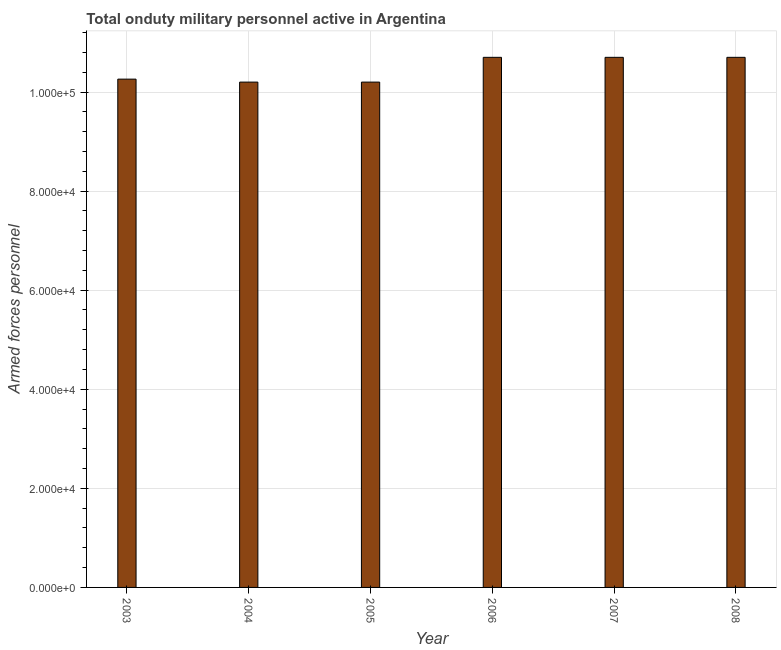Does the graph contain any zero values?
Give a very brief answer. No. Does the graph contain grids?
Offer a very short reply. Yes. What is the title of the graph?
Provide a succinct answer. Total onduty military personnel active in Argentina. What is the label or title of the Y-axis?
Your response must be concise. Armed forces personnel. What is the number of armed forces personnel in 2007?
Provide a short and direct response. 1.07e+05. Across all years, what is the maximum number of armed forces personnel?
Ensure brevity in your answer.  1.07e+05. Across all years, what is the minimum number of armed forces personnel?
Provide a short and direct response. 1.02e+05. What is the sum of the number of armed forces personnel?
Ensure brevity in your answer.  6.28e+05. What is the average number of armed forces personnel per year?
Your answer should be very brief. 1.05e+05. What is the median number of armed forces personnel?
Your answer should be very brief. 1.05e+05. What is the ratio of the number of armed forces personnel in 2007 to that in 2008?
Provide a succinct answer. 1. Is the number of armed forces personnel in 2003 less than that in 2005?
Your answer should be compact. No. Is the difference between the number of armed forces personnel in 2004 and 2006 greater than the difference between any two years?
Make the answer very short. Yes. In how many years, is the number of armed forces personnel greater than the average number of armed forces personnel taken over all years?
Offer a very short reply. 3. How many years are there in the graph?
Your response must be concise. 6. What is the difference between two consecutive major ticks on the Y-axis?
Provide a short and direct response. 2.00e+04. What is the Armed forces personnel in 2003?
Offer a very short reply. 1.03e+05. What is the Armed forces personnel in 2004?
Provide a short and direct response. 1.02e+05. What is the Armed forces personnel in 2005?
Ensure brevity in your answer.  1.02e+05. What is the Armed forces personnel in 2006?
Offer a very short reply. 1.07e+05. What is the Armed forces personnel of 2007?
Make the answer very short. 1.07e+05. What is the Armed forces personnel in 2008?
Make the answer very short. 1.07e+05. What is the difference between the Armed forces personnel in 2003 and 2004?
Offer a very short reply. 600. What is the difference between the Armed forces personnel in 2003 and 2005?
Ensure brevity in your answer.  600. What is the difference between the Armed forces personnel in 2003 and 2006?
Give a very brief answer. -4400. What is the difference between the Armed forces personnel in 2003 and 2007?
Ensure brevity in your answer.  -4400. What is the difference between the Armed forces personnel in 2003 and 2008?
Make the answer very short. -4400. What is the difference between the Armed forces personnel in 2004 and 2006?
Keep it short and to the point. -5000. What is the difference between the Armed forces personnel in 2004 and 2007?
Provide a succinct answer. -5000. What is the difference between the Armed forces personnel in 2004 and 2008?
Provide a succinct answer. -5000. What is the difference between the Armed forces personnel in 2005 and 2006?
Provide a succinct answer. -5000. What is the difference between the Armed forces personnel in 2005 and 2007?
Provide a succinct answer. -5000. What is the difference between the Armed forces personnel in 2005 and 2008?
Give a very brief answer. -5000. What is the difference between the Armed forces personnel in 2006 and 2008?
Keep it short and to the point. 0. What is the ratio of the Armed forces personnel in 2003 to that in 2004?
Make the answer very short. 1.01. What is the ratio of the Armed forces personnel in 2003 to that in 2007?
Offer a very short reply. 0.96. What is the ratio of the Armed forces personnel in 2003 to that in 2008?
Keep it short and to the point. 0.96. What is the ratio of the Armed forces personnel in 2004 to that in 2005?
Provide a short and direct response. 1. What is the ratio of the Armed forces personnel in 2004 to that in 2006?
Provide a succinct answer. 0.95. What is the ratio of the Armed forces personnel in 2004 to that in 2007?
Keep it short and to the point. 0.95. What is the ratio of the Armed forces personnel in 2004 to that in 2008?
Keep it short and to the point. 0.95. What is the ratio of the Armed forces personnel in 2005 to that in 2006?
Keep it short and to the point. 0.95. What is the ratio of the Armed forces personnel in 2005 to that in 2007?
Keep it short and to the point. 0.95. What is the ratio of the Armed forces personnel in 2005 to that in 2008?
Give a very brief answer. 0.95. What is the ratio of the Armed forces personnel in 2006 to that in 2007?
Your response must be concise. 1. What is the ratio of the Armed forces personnel in 2007 to that in 2008?
Your answer should be compact. 1. 